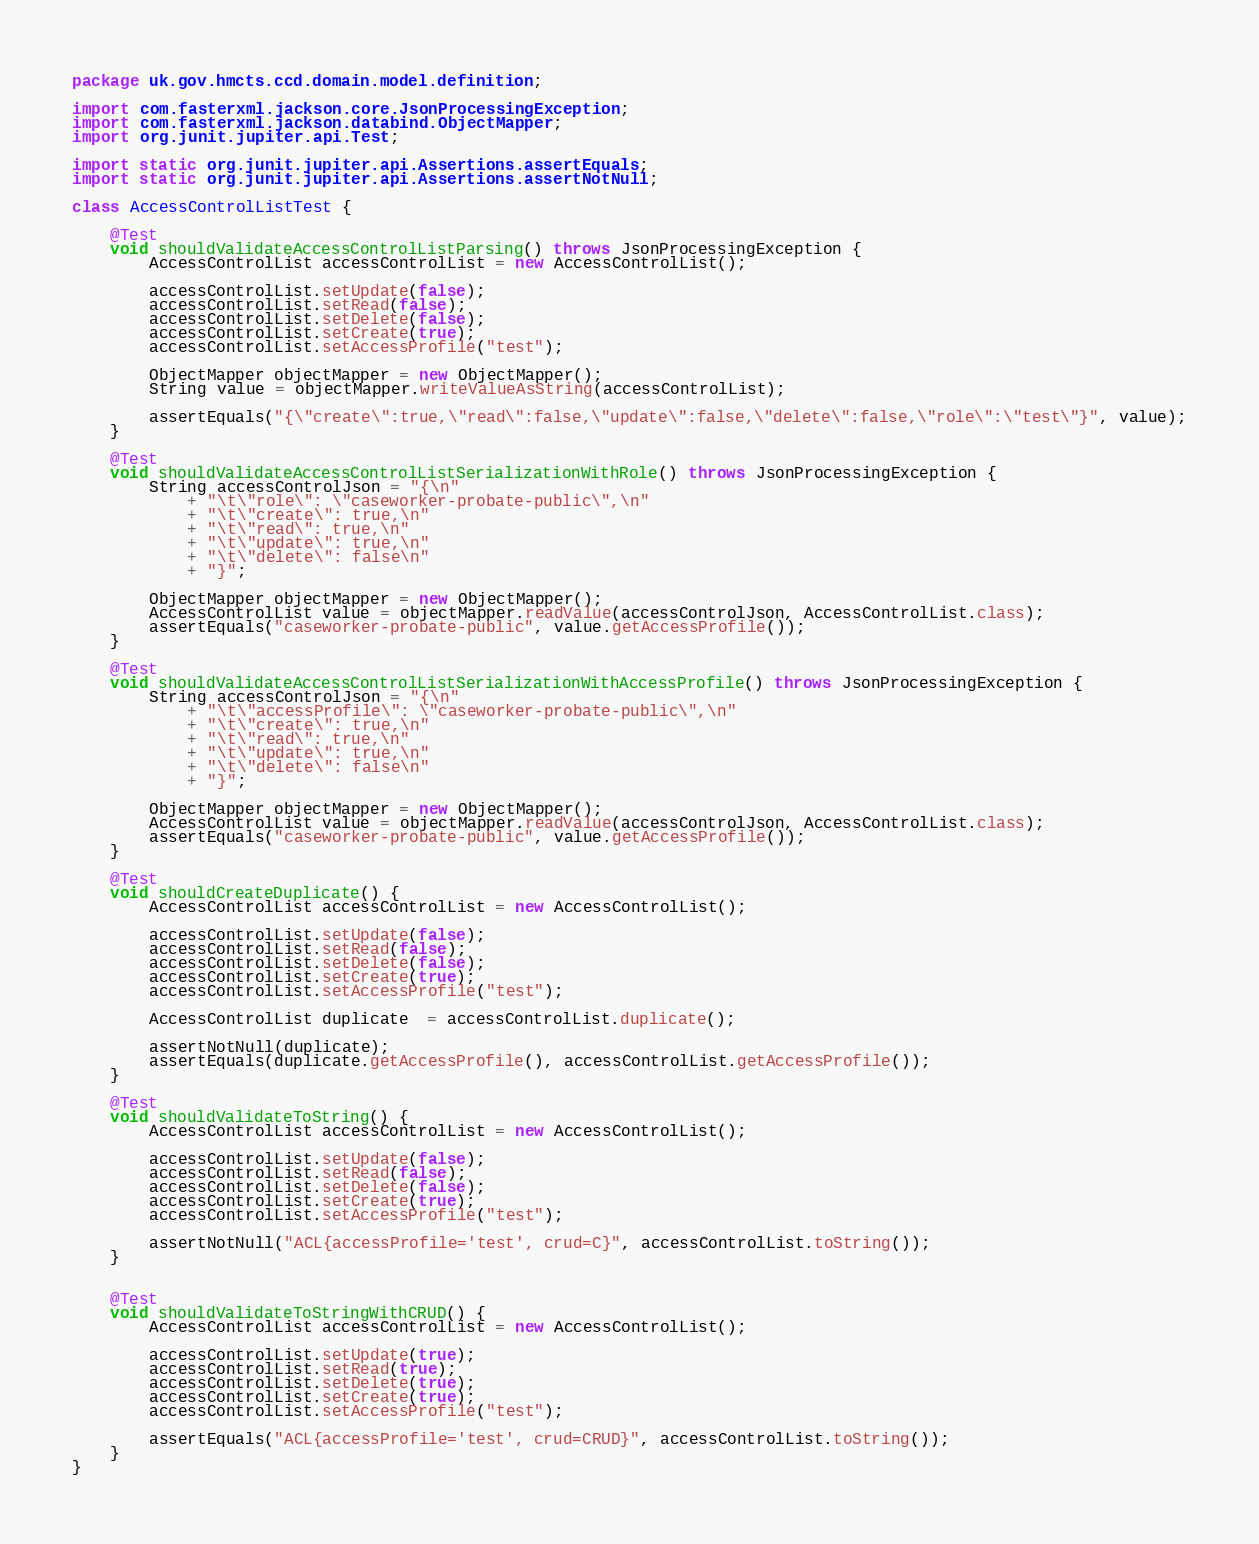Convert code to text. <code><loc_0><loc_0><loc_500><loc_500><_Java_>package uk.gov.hmcts.ccd.domain.model.definition;

import com.fasterxml.jackson.core.JsonProcessingException;
import com.fasterxml.jackson.databind.ObjectMapper;
import org.junit.jupiter.api.Test;

import static org.junit.jupiter.api.Assertions.assertEquals;
import static org.junit.jupiter.api.Assertions.assertNotNull;

class AccessControlListTest {

    @Test
    void shouldValidateAccessControlListParsing() throws JsonProcessingException {
        AccessControlList accessControlList = new AccessControlList();

        accessControlList.setUpdate(false);
        accessControlList.setRead(false);
        accessControlList.setDelete(false);
        accessControlList.setCreate(true);
        accessControlList.setAccessProfile("test");

        ObjectMapper objectMapper = new ObjectMapper();
        String value = objectMapper.writeValueAsString(accessControlList);

        assertEquals("{\"create\":true,\"read\":false,\"update\":false,\"delete\":false,\"role\":\"test\"}", value);
    }

    @Test
    void shouldValidateAccessControlListSerializationWithRole() throws JsonProcessingException {
        String accessControlJson = "{\n"
            + "\t\"role\": \"caseworker-probate-public\",\n"
            + "\t\"create\": true,\n"
            + "\t\"read\": true,\n"
            + "\t\"update\": true,\n"
            + "\t\"delete\": false\n"
            + "}";

        ObjectMapper objectMapper = new ObjectMapper();
        AccessControlList value = objectMapper.readValue(accessControlJson, AccessControlList.class);
        assertEquals("caseworker-probate-public", value.getAccessProfile());
    }

    @Test
    void shouldValidateAccessControlListSerializationWithAccessProfile() throws JsonProcessingException {
        String accessControlJson = "{\n"
            + "\t\"accessProfile\": \"caseworker-probate-public\",\n"
            + "\t\"create\": true,\n"
            + "\t\"read\": true,\n"
            + "\t\"update\": true,\n"
            + "\t\"delete\": false\n"
            + "}";

        ObjectMapper objectMapper = new ObjectMapper();
        AccessControlList value = objectMapper.readValue(accessControlJson, AccessControlList.class);
        assertEquals("caseworker-probate-public", value.getAccessProfile());
    }

    @Test
    void shouldCreateDuplicate() {
        AccessControlList accessControlList = new AccessControlList();

        accessControlList.setUpdate(false);
        accessControlList.setRead(false);
        accessControlList.setDelete(false);
        accessControlList.setCreate(true);
        accessControlList.setAccessProfile("test");

        AccessControlList duplicate  = accessControlList.duplicate();

        assertNotNull(duplicate);
        assertEquals(duplicate.getAccessProfile(), accessControlList.getAccessProfile());
    }

    @Test
    void shouldValidateToString() {
        AccessControlList accessControlList = new AccessControlList();

        accessControlList.setUpdate(false);
        accessControlList.setRead(false);
        accessControlList.setDelete(false);
        accessControlList.setCreate(true);
        accessControlList.setAccessProfile("test");

        assertNotNull("ACL{accessProfile='test', crud=C}", accessControlList.toString());
    }


    @Test
    void shouldValidateToStringWithCRUD() {
        AccessControlList accessControlList = new AccessControlList();

        accessControlList.setUpdate(true);
        accessControlList.setRead(true);
        accessControlList.setDelete(true);
        accessControlList.setCreate(true);
        accessControlList.setAccessProfile("test");

        assertEquals("ACL{accessProfile='test', crud=CRUD}", accessControlList.toString());
    }
}
</code> 